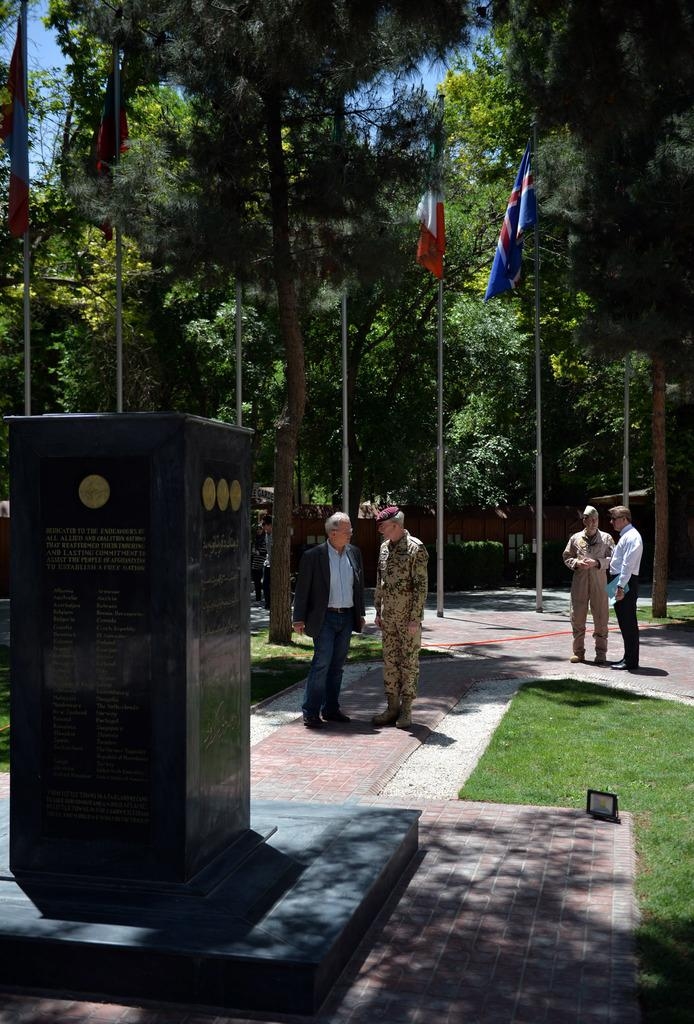What is located on the left side of the image? There is a foundation stone on the left side of the image. What can be seen in the center of the image? There are soldiers and people in the center of the image. What type of vegetation is on the right side of the image? There is grass on the right side of the image. What is visible in the background of the image? There are flags, trees, and the sky visible in the background of the image. What type of ice can be seen melting on the foundation stone in the image? There is no ice present in the image; it features a foundation stone, soldiers, people, grass, flags, trees, and the sky. What color is the ink used to write on the flags in the image? There is no ink visible in the image, as the flags are not shown with any writing or text. 